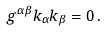<formula> <loc_0><loc_0><loc_500><loc_500>g ^ { \alpha \beta } k _ { \alpha } k _ { \beta } = 0 \, .</formula> 